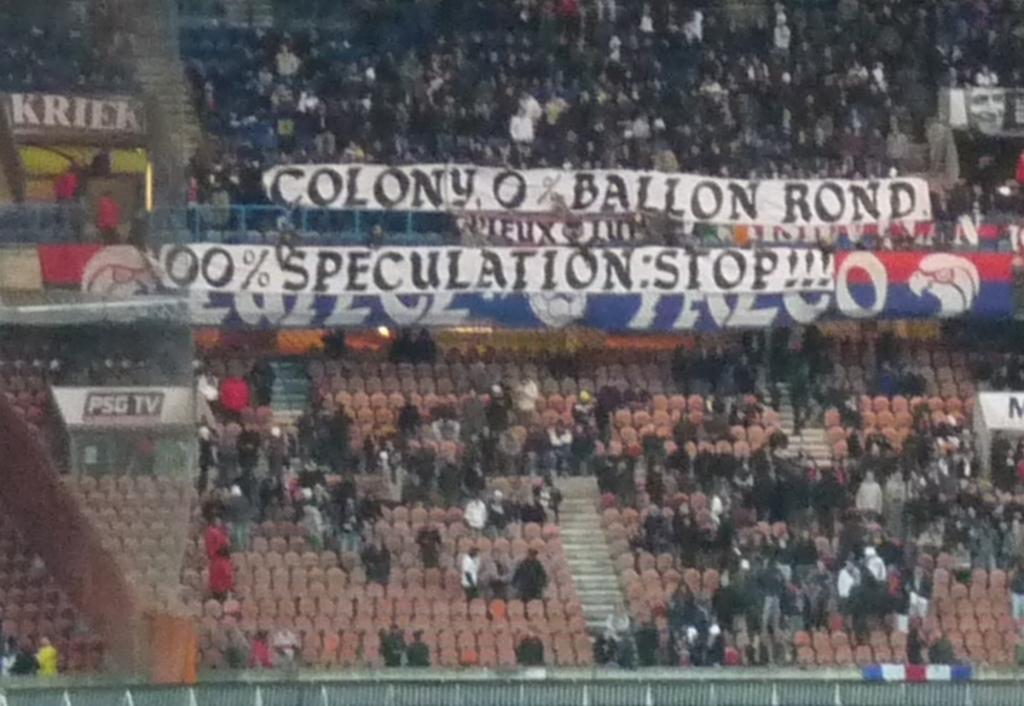<image>
Provide a brief description of the given image. Banners are held up in an arena reading Colony 0% Ballon Rond and 100% Speculation: Stop. 